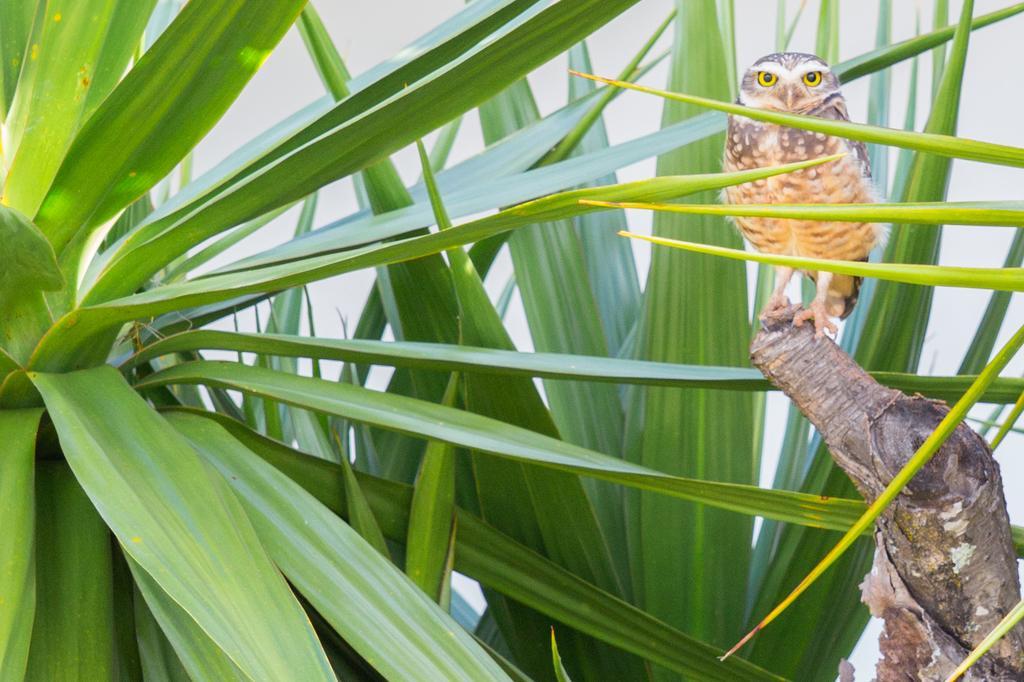How would you summarize this image in a sentence or two? In this image we can see one owl on the tree stump, some plants on the ground and there is a white background. 